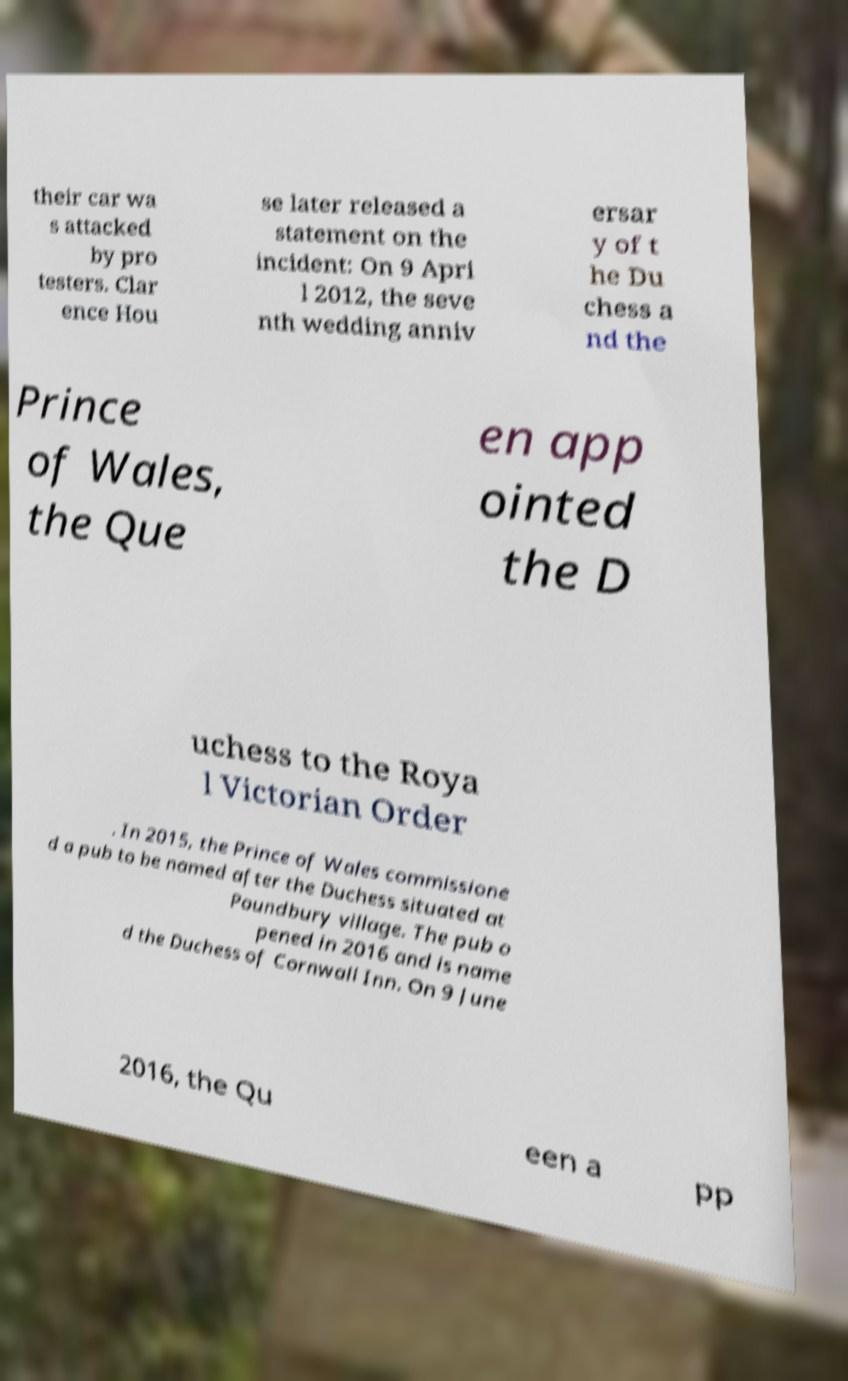Could you assist in decoding the text presented in this image and type it out clearly? their car wa s attacked by pro testers. Clar ence Hou se later released a statement on the incident: On 9 Apri l 2012, the seve nth wedding anniv ersar y of t he Du chess a nd the Prince of Wales, the Que en app ointed the D uchess to the Roya l Victorian Order . In 2015, the Prince of Wales commissione d a pub to be named after the Duchess situated at Poundbury village. The pub o pened in 2016 and is name d the Duchess of Cornwall Inn. On 9 June 2016, the Qu een a pp 